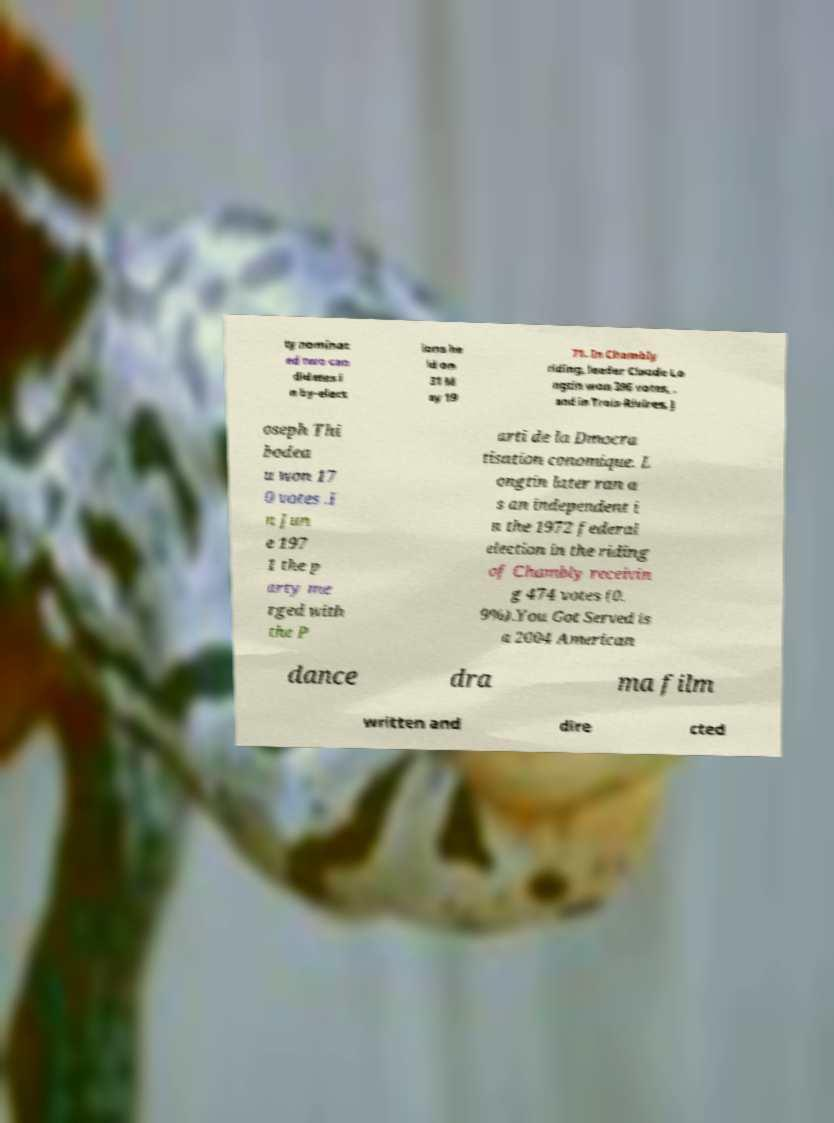Please identify and transcribe the text found in this image. ty nominat ed two can didates i n by-elect ions he ld on 31 M ay 19 71. In Chambly riding, leader Claude Lo ngtin won 396 votes, , and in Trois-Rivires, J oseph Thi bodea u won 17 0 votes .I n Jun e 197 1 the p arty me rged with the P arti de la Dmocra tisation conomique. L ongtin later ran a s an independent i n the 1972 federal election in the riding of Chambly receivin g 474 votes (0. 9%).You Got Served is a 2004 American dance dra ma film written and dire cted 